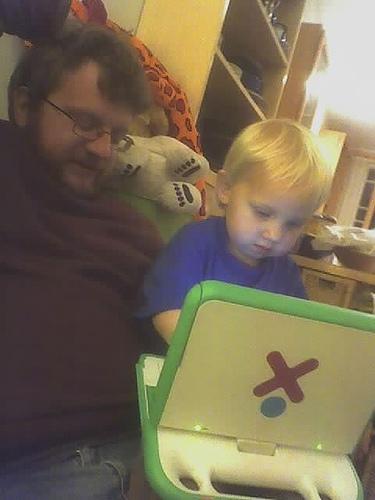Is the man wearing eyeglasses?
Concise answer only. Yes. What color is the boys hair?
Concise answer only. Blonde. Is daddy just observing?
Answer briefly. Yes. 